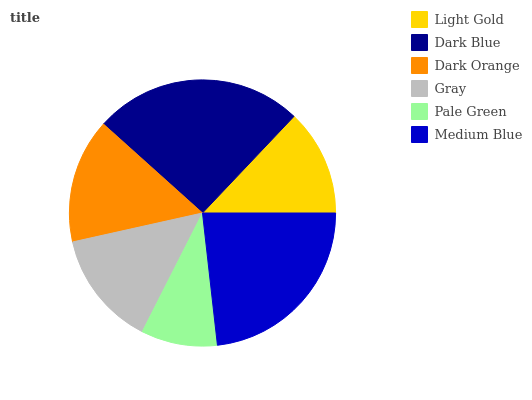Is Pale Green the minimum?
Answer yes or no. Yes. Is Dark Blue the maximum?
Answer yes or no. Yes. Is Dark Orange the minimum?
Answer yes or no. No. Is Dark Orange the maximum?
Answer yes or no. No. Is Dark Blue greater than Dark Orange?
Answer yes or no. Yes. Is Dark Orange less than Dark Blue?
Answer yes or no. Yes. Is Dark Orange greater than Dark Blue?
Answer yes or no. No. Is Dark Blue less than Dark Orange?
Answer yes or no. No. Is Dark Orange the high median?
Answer yes or no. Yes. Is Gray the low median?
Answer yes or no. Yes. Is Medium Blue the high median?
Answer yes or no. No. Is Dark Blue the low median?
Answer yes or no. No. 